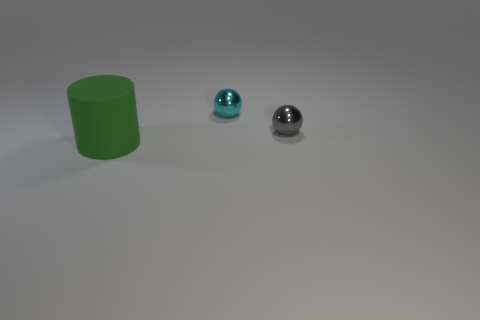Add 1 small matte objects. How many objects exist? 4 Subtract all cylinders. How many objects are left? 2 Add 1 tiny gray objects. How many tiny gray objects are left? 2 Add 2 big yellow matte objects. How many big yellow matte objects exist? 2 Subtract 1 gray balls. How many objects are left? 2 Subtract all metal balls. Subtract all small blue rubber things. How many objects are left? 1 